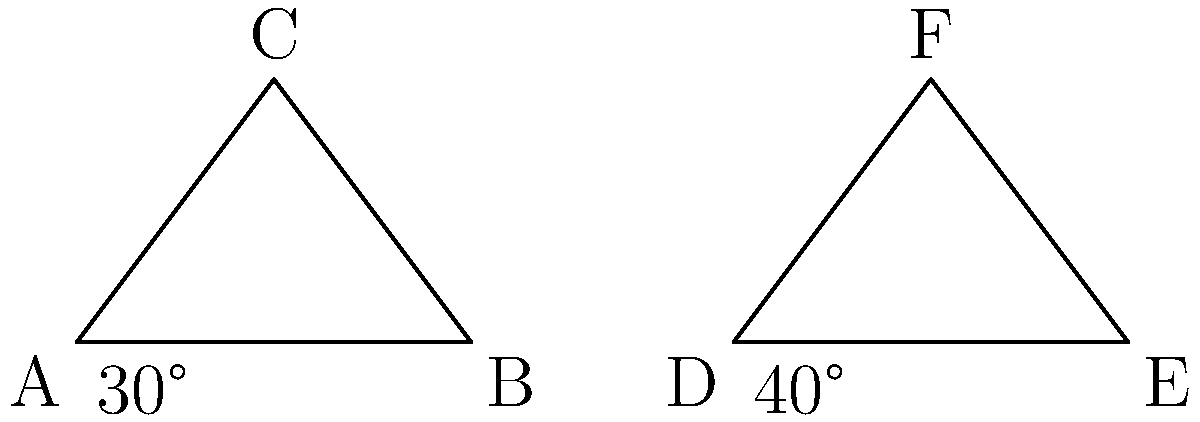During a practice session at Kelso rugby field, you notice two different goalposts. The angles at the base of these goalposts are shown in the diagram. If triangle ABC is congruent to triangle DEF, what is the measure of angle BAC? Let's approach this step-by-step:

1) We're told that triangle ABC is congruent to triangle DEF.

2) In triangle DEF, we can see that the angle at D is 40°.

3) In congruent triangles, corresponding angles are equal.

4) Therefore, angle BAC in triangle ABC must also be 40°.

5) We can verify this using the fact that the sum of angles in a triangle is always 180°:
   
   $$40° + 30° + \angle ACB = 180°$$
   
   $$\angle ACB = 180° - 70° = 110°$$

6) This confirms that angle BAC is indeed 40°, as the three angles in triangle ABC (40°, 30°, and 110°) sum to 180°.
Answer: 40° 